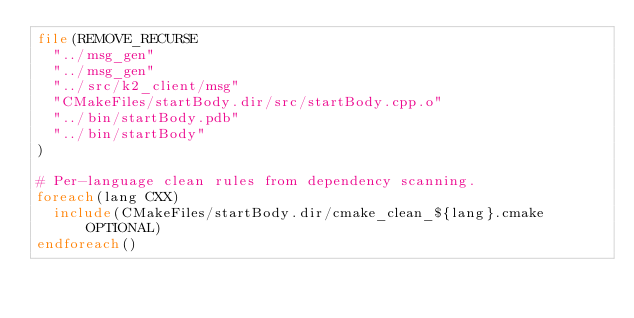<code> <loc_0><loc_0><loc_500><loc_500><_CMake_>file(REMOVE_RECURSE
  "../msg_gen"
  "../msg_gen"
  "../src/k2_client/msg"
  "CMakeFiles/startBody.dir/src/startBody.cpp.o"
  "../bin/startBody.pdb"
  "../bin/startBody"
)

# Per-language clean rules from dependency scanning.
foreach(lang CXX)
  include(CMakeFiles/startBody.dir/cmake_clean_${lang}.cmake OPTIONAL)
endforeach()
</code> 